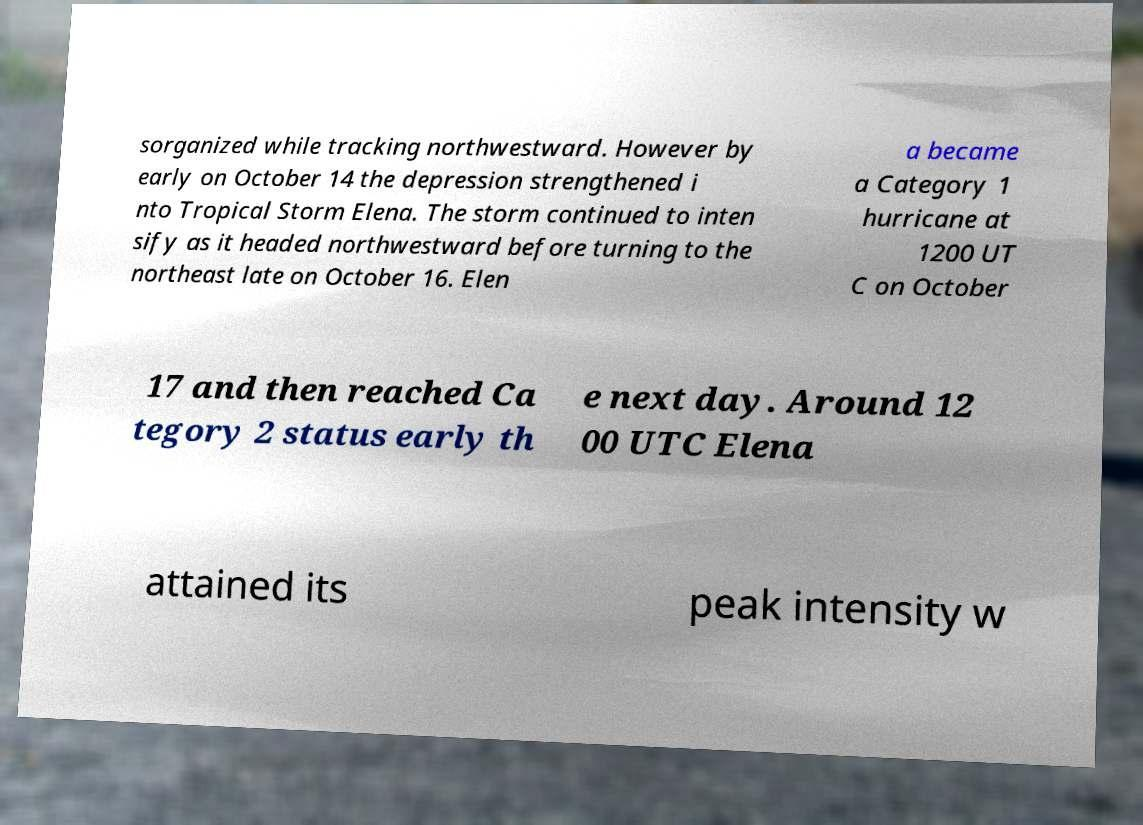There's text embedded in this image that I need extracted. Can you transcribe it verbatim? sorganized while tracking northwestward. However by early on October 14 the depression strengthened i nto Tropical Storm Elena. The storm continued to inten sify as it headed northwestward before turning to the northeast late on October 16. Elen a became a Category 1 hurricane at 1200 UT C on October 17 and then reached Ca tegory 2 status early th e next day. Around 12 00 UTC Elena attained its peak intensity w 